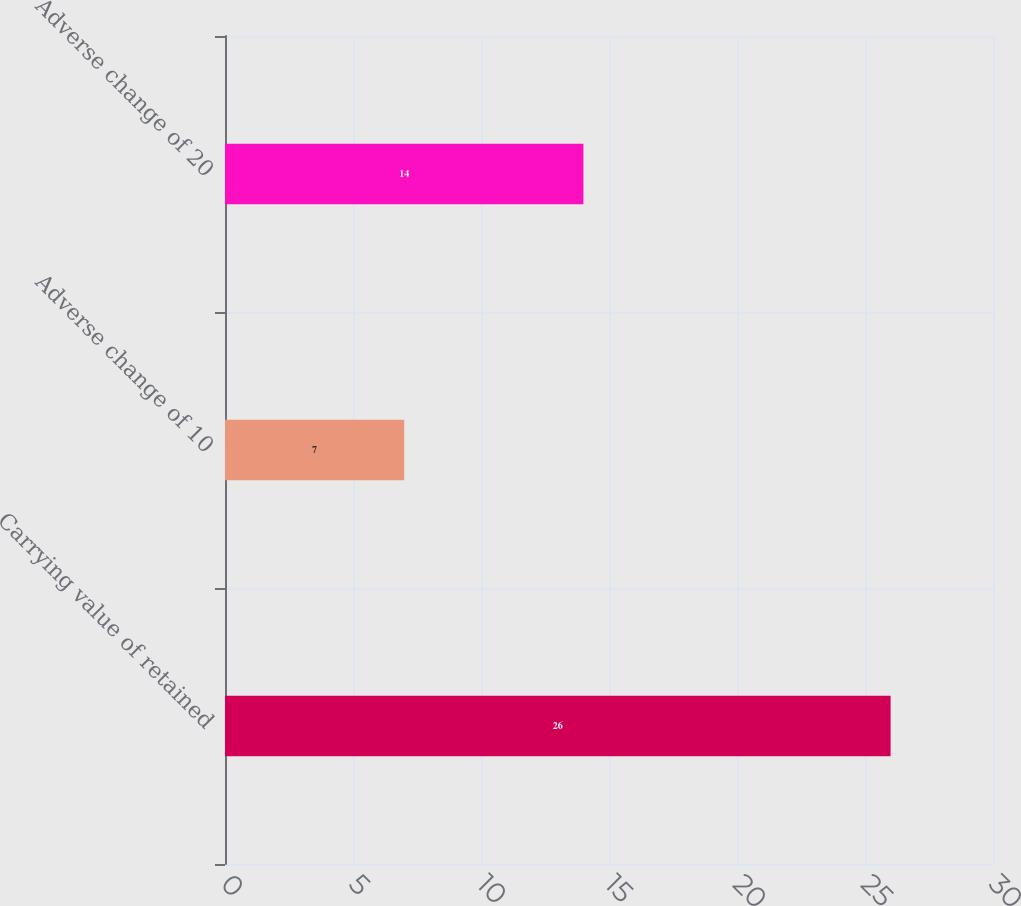<chart> <loc_0><loc_0><loc_500><loc_500><bar_chart><fcel>Carrying value of retained<fcel>Adverse change of 10<fcel>Adverse change of 20<nl><fcel>26<fcel>7<fcel>14<nl></chart> 